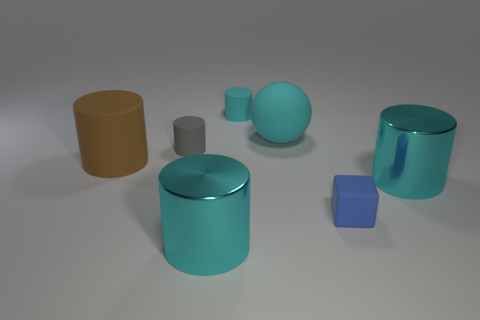How many objects are either matte objects or tiny blue rubber balls?
Make the answer very short. 5. Does the large cyan matte thing have the same shape as the gray thing?
Ensure brevity in your answer.  No. Is there a big green object that has the same material as the gray cylinder?
Ensure brevity in your answer.  No. Are there any large cylinders that are behind the small cylinder behind the gray matte cylinder?
Offer a terse response. No. There is a cyan rubber thing that is behind the cyan rubber ball; is it the same size as the gray object?
Offer a terse response. Yes. The block has what size?
Offer a terse response. Small. Is there a rubber cylinder that has the same color as the ball?
Your response must be concise. Yes. What number of small things are cyan objects or blue things?
Ensure brevity in your answer.  2. What is the size of the cylinder that is both in front of the large brown matte cylinder and behind the cube?
Offer a very short reply. Large. There is a rubber ball; how many cubes are behind it?
Your response must be concise. 0. 